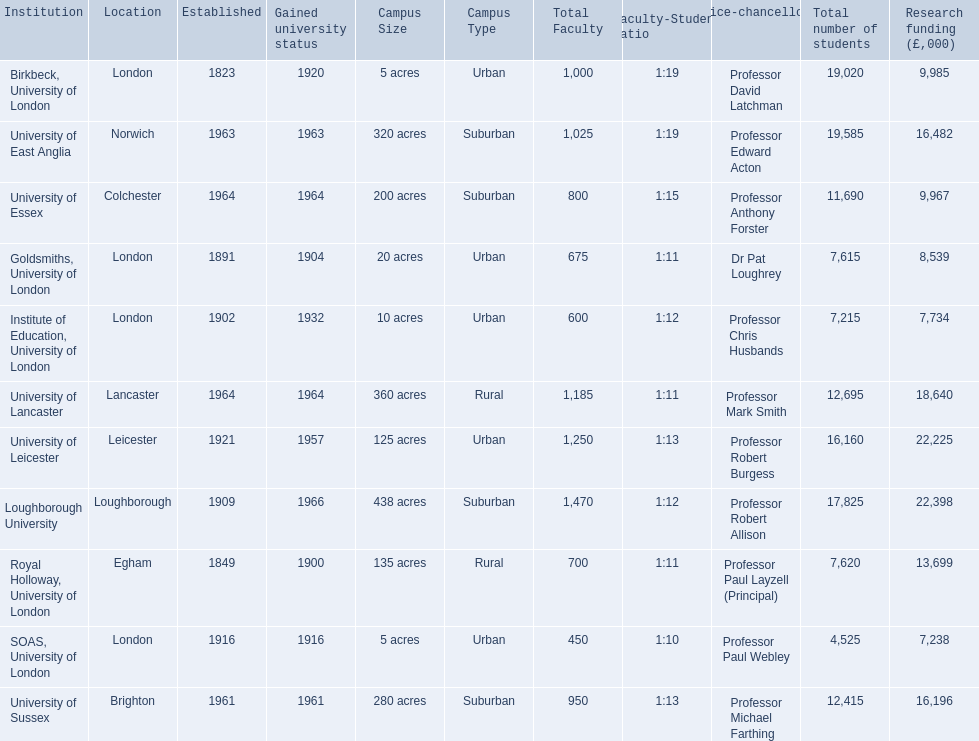What are the names of all the institutions? Birkbeck, University of London, University of East Anglia, University of Essex, Goldsmiths, University of London, Institute of Education, University of London, University of Lancaster, University of Leicester, Loughborough University, Royal Holloway, University of London, SOAS, University of London, University of Sussex. In what range of years were these institutions established? 1823, 1963, 1964, 1891, 1902, 1964, 1921, 1909, 1849, 1916, 1961. In what range of years did these institutions gain university status? 1920, 1963, 1964, 1904, 1932, 1964, 1957, 1966, 1900, 1916, 1961. What institution most recently gained university status? Loughborough University. 